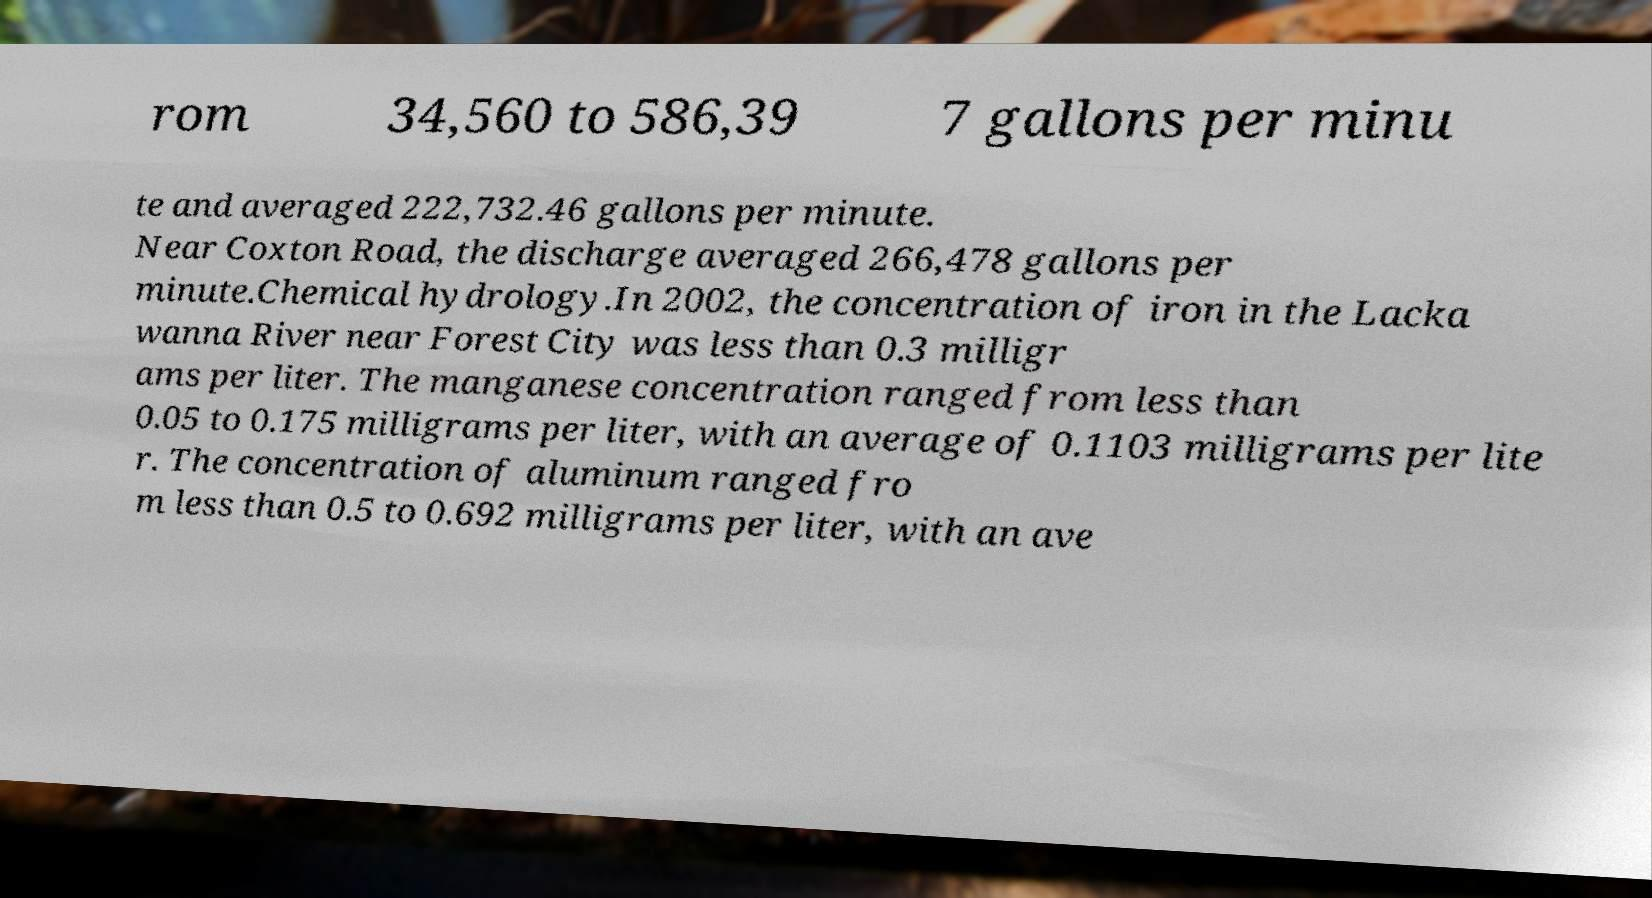Can you accurately transcribe the text from the provided image for me? rom 34,560 to 586,39 7 gallons per minu te and averaged 222,732.46 gallons per minute. Near Coxton Road, the discharge averaged 266,478 gallons per minute.Chemical hydrology.In 2002, the concentration of iron in the Lacka wanna River near Forest City was less than 0.3 milligr ams per liter. The manganese concentration ranged from less than 0.05 to 0.175 milligrams per liter, with an average of 0.1103 milligrams per lite r. The concentration of aluminum ranged fro m less than 0.5 to 0.692 milligrams per liter, with an ave 